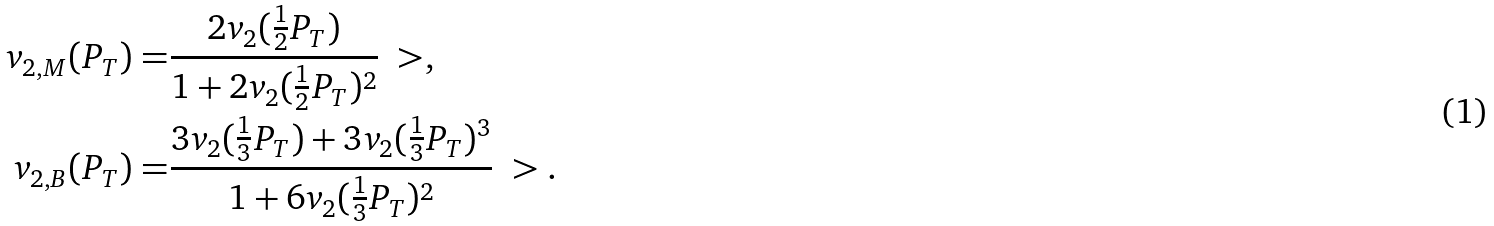<formula> <loc_0><loc_0><loc_500><loc_500>v _ { 2 , M } ( P _ { T } ) = & \frac { 2 v _ { 2 } ( \frac { 1 } { 2 } P _ { T } ) } { 1 + 2 v _ { 2 } ( \frac { 1 } { 2 } P _ { T } ) ^ { 2 } } \ > , \\ v _ { 2 , B } ( P _ { T } ) = & \frac { 3 v _ { 2 } ( \frac { 1 } { 3 } P _ { T } ) + 3 v _ { 2 } ( \frac { 1 } { 3 } P _ { T } ) ^ { 3 } } { 1 + 6 v _ { 2 } ( \frac { 1 } { 3 } P _ { T } ) ^ { 2 } } \ > .</formula> 